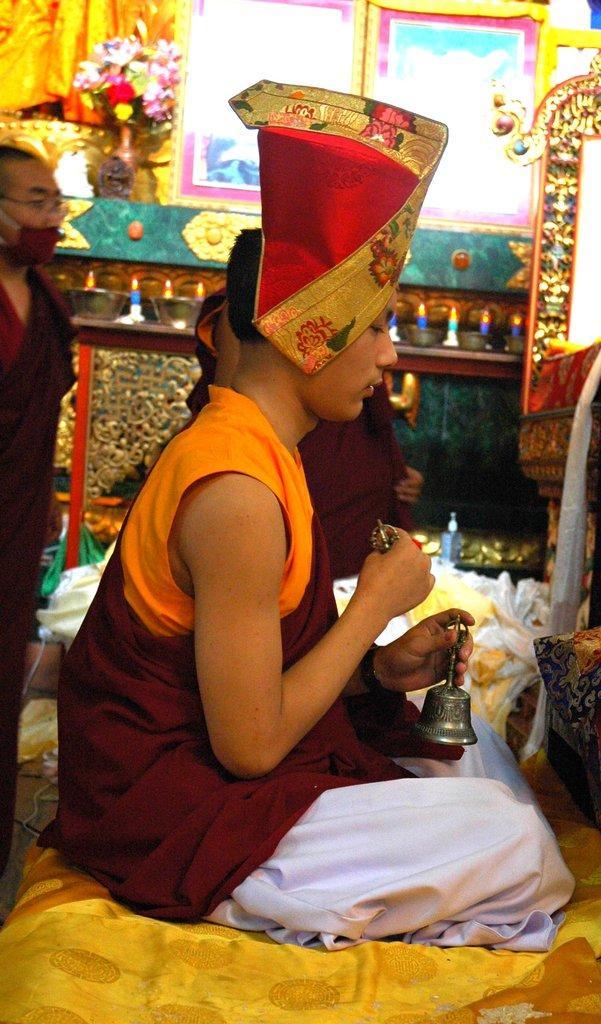Can you describe this image briefly? In this image we can see men sitting and standing on the floor. In the background there are decors, electric lights and walls. 